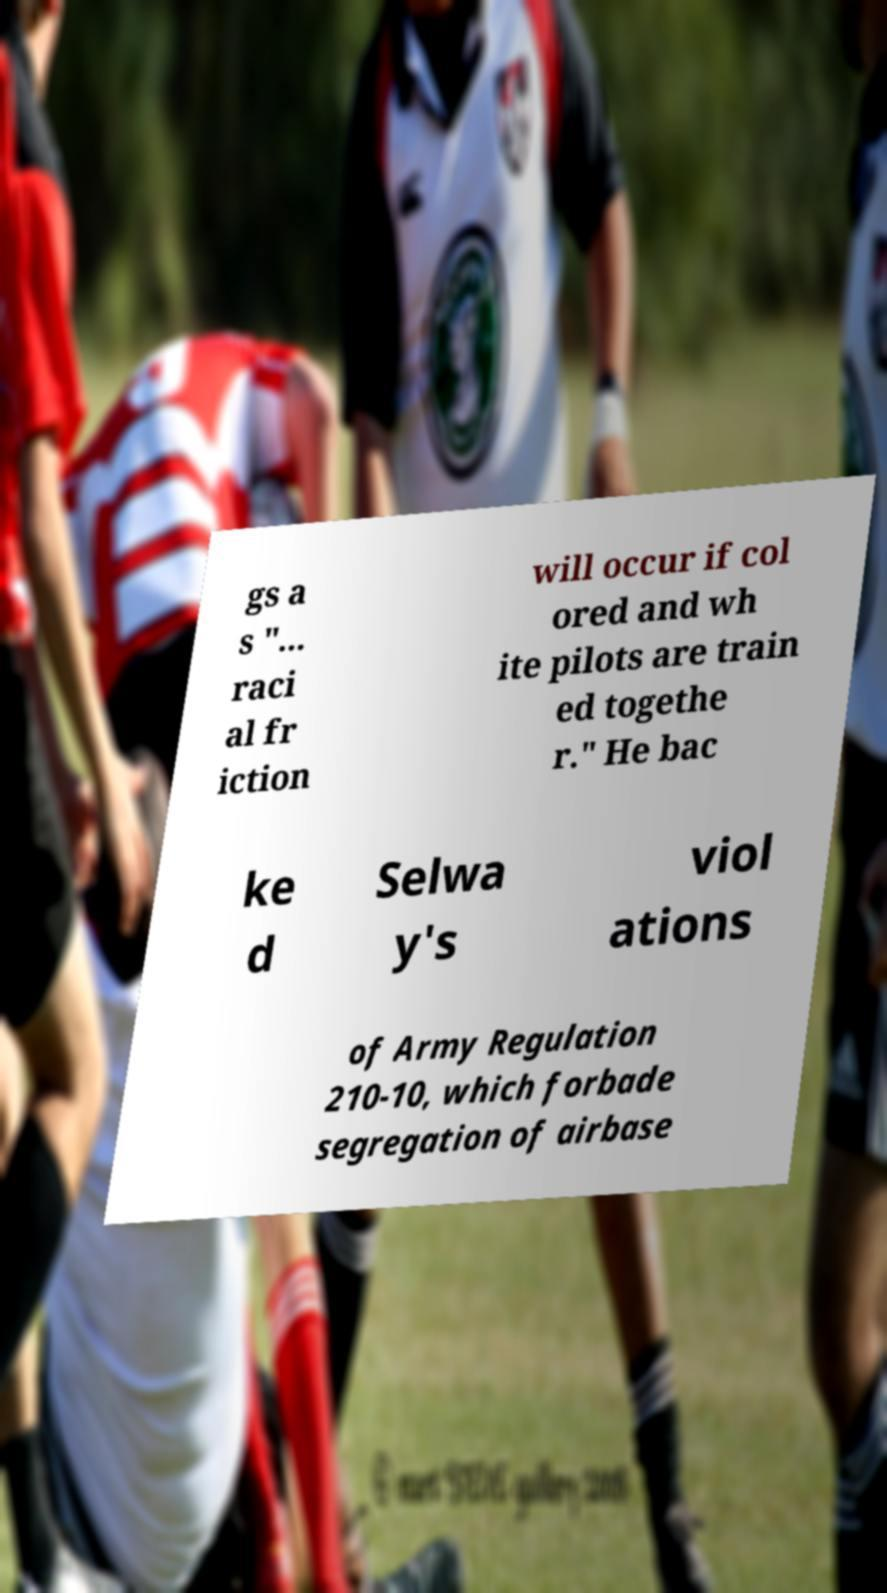There's text embedded in this image that I need extracted. Can you transcribe it verbatim? gs a s "... raci al fr iction will occur if col ored and wh ite pilots are train ed togethe r." He bac ke d Selwa y's viol ations of Army Regulation 210-10, which forbade segregation of airbase 